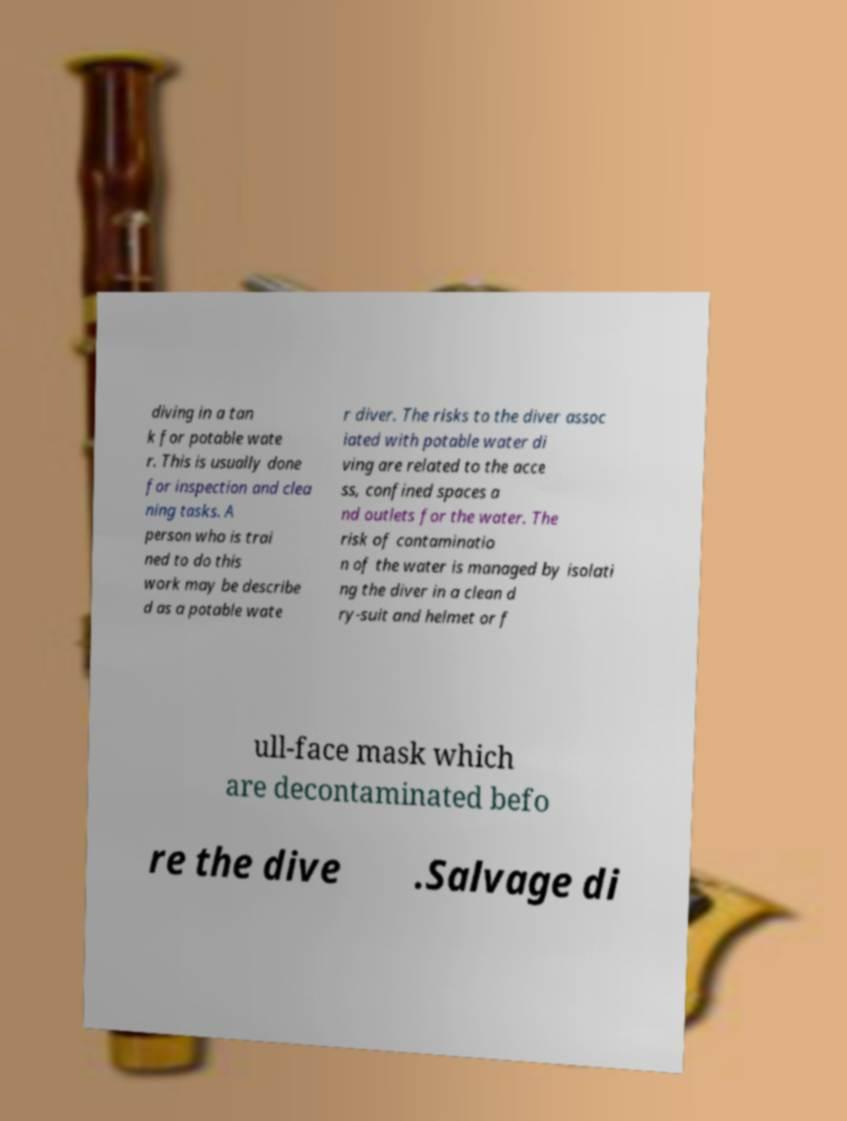What messages or text are displayed in this image? I need them in a readable, typed format. diving in a tan k for potable wate r. This is usually done for inspection and clea ning tasks. A person who is trai ned to do this work may be describe d as a potable wate r diver. The risks to the diver assoc iated with potable water di ving are related to the acce ss, confined spaces a nd outlets for the water. The risk of contaminatio n of the water is managed by isolati ng the diver in a clean d ry-suit and helmet or f ull-face mask which are decontaminated befo re the dive .Salvage di 